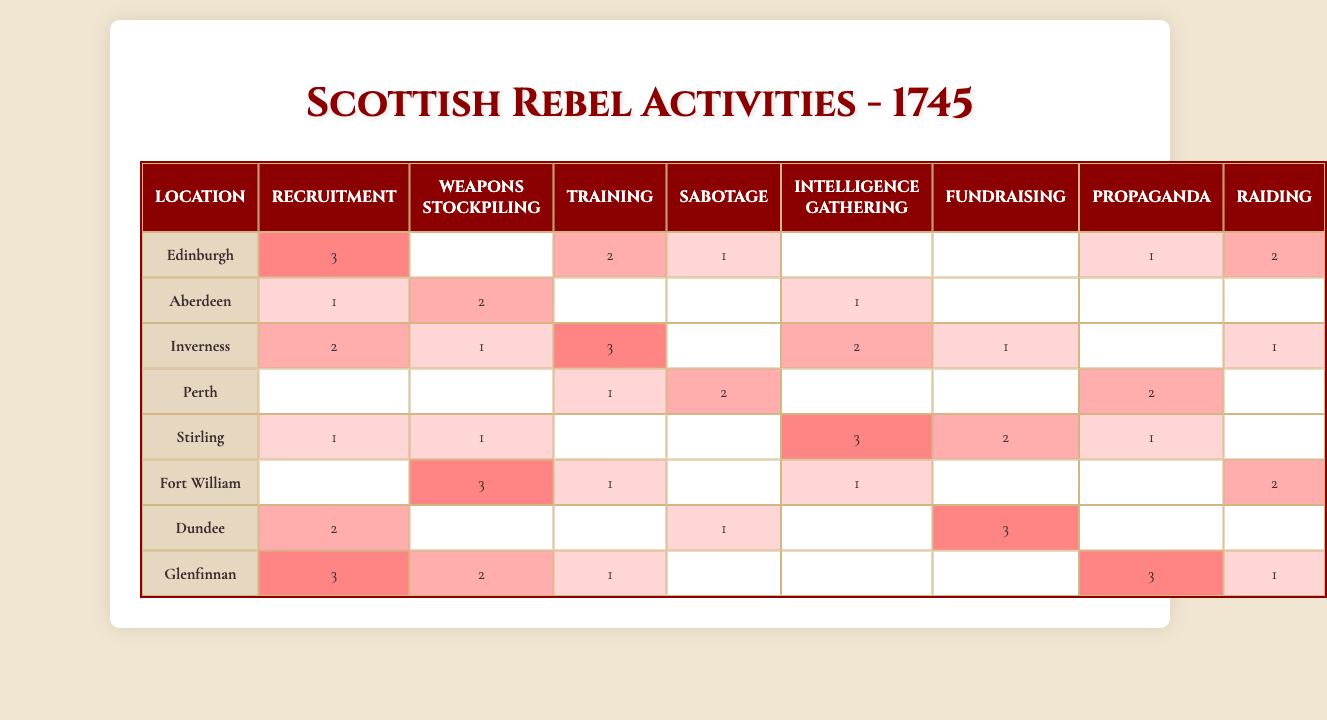What location has the highest level of sabotage activity? In the table, "sabotage" activity is represented by the 4th column. Looking at the data, Fort William has a level of 2, which is the highest for this activity, while no other location exceeds this level.
Answer: Fort William How many locations have a recruitment activity level of 3? By examining the first column for "recruitment," we can see that Edinburgh and Glenfinnan both have a level of 3, thus there are two locations with this level of recruitment activity.
Answer: 2 What is the total number of fundraising activities across all locations? To find the total number of fundraising activities, we sum the values in the 6th column. The values are 0 (Edinburgh) + 0 (Aberdeen) + 1 (Inverness) + 0 (Perth) + 2 (Stirling) + 0 (Fort William) + 3 (Dundee) + 0 (Glenfinnan), which totals 6.
Answer: 6 Which location shows a significant presence in training and has a higher level of propaganda? We compare the values in the 3rd column (training) and the 7th column (propaganda). Upon checking, Perth has a training level of 2 and a propaganda level of 2, but Stirling has a higher propaganda level of 1 but lower training level. Thus, among the options, only Inverness has training activity level of 3 and propaganda of 0. Therefore, no location has both attributes where training is high and propaganda is also higher than training.
Answer: None Is there any location where weapons stockpiling activity has a level of 0? Upon reviewing the 2nd column for "weapons stockpiling," both Edinburgh and Inverness have levels of 0. This confirms that such locations exist.
Answer: Yes What is the average level of training activities across all locations? To determine the average of training activities, we sum the values from the 3rd column: 2 + 0 + 3 + 1 + 0 + 1 + 0 + 1 = 8. Since there are 8 locations, the average is 8/8 = 1.
Answer: 1 Which activity has the highest average count across all locations? To find the highest average, we compute the sums of each activity and divide by the number of locations for each column. For recruitment, the total is 3+1+2+0+1+0+2+3 = 12; for weapons stockpiling, the total is 0+2+1+0+1+3+0+2 = 9; and for training, it's 8; sabotage is 4; intelligence is 7; fundraising is 6; propaganda is 6; raiding is 5. The highest average is from recruitment (12/8 = 1.5). Thus, recruitment has the highest average.
Answer: Recruitment How many activities in total did Stirling engage in? To find the total activities for Stirling, we add the values in its row: 1 (recruitment) + 0 (weapons stockpiling) + 0 (training) + 0 (sabotage) + 3 (intelligence gathering) + 2 (fundraising) + 1 (propaganda) + 0 (raiding), which sums to 7 activities in total.
Answer: 7 Which location has a higher level of recruiting than Dundee's weapons stockpiling? Dundee has a level of 2 in weapons stockpiling. Comparing all locations, Edinburgh has a recruiting level of 3, which is higher than Dundee's weapons stockpiling level, while Aberdeen has a recruitment level of 1. Therefore, the location with a higher recruitment than Dundee's weapons stockpiling is Edinburgh.
Answer: Edinburgh How does the level of raiding in Glenfinnan compare to that of Fort William? In Glenfinnan, the raiding activity level is 1, while Fort William has a level of 2 in raiding. Thus, Glenfinnan has a lower level of raiding compared to Fort William.
Answer: Glenfinnan has a lower level 